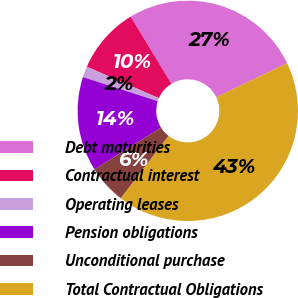Convert chart. <chart><loc_0><loc_0><loc_500><loc_500><pie_chart><fcel>Debt maturities<fcel>Contractual interest<fcel>Operating leases<fcel>Pension obligations<fcel>Unconditional purchase<fcel>Total Contractual Obligations<nl><fcel>26.55%<fcel>9.78%<fcel>1.6%<fcel>13.87%<fcel>5.69%<fcel>42.51%<nl></chart> 